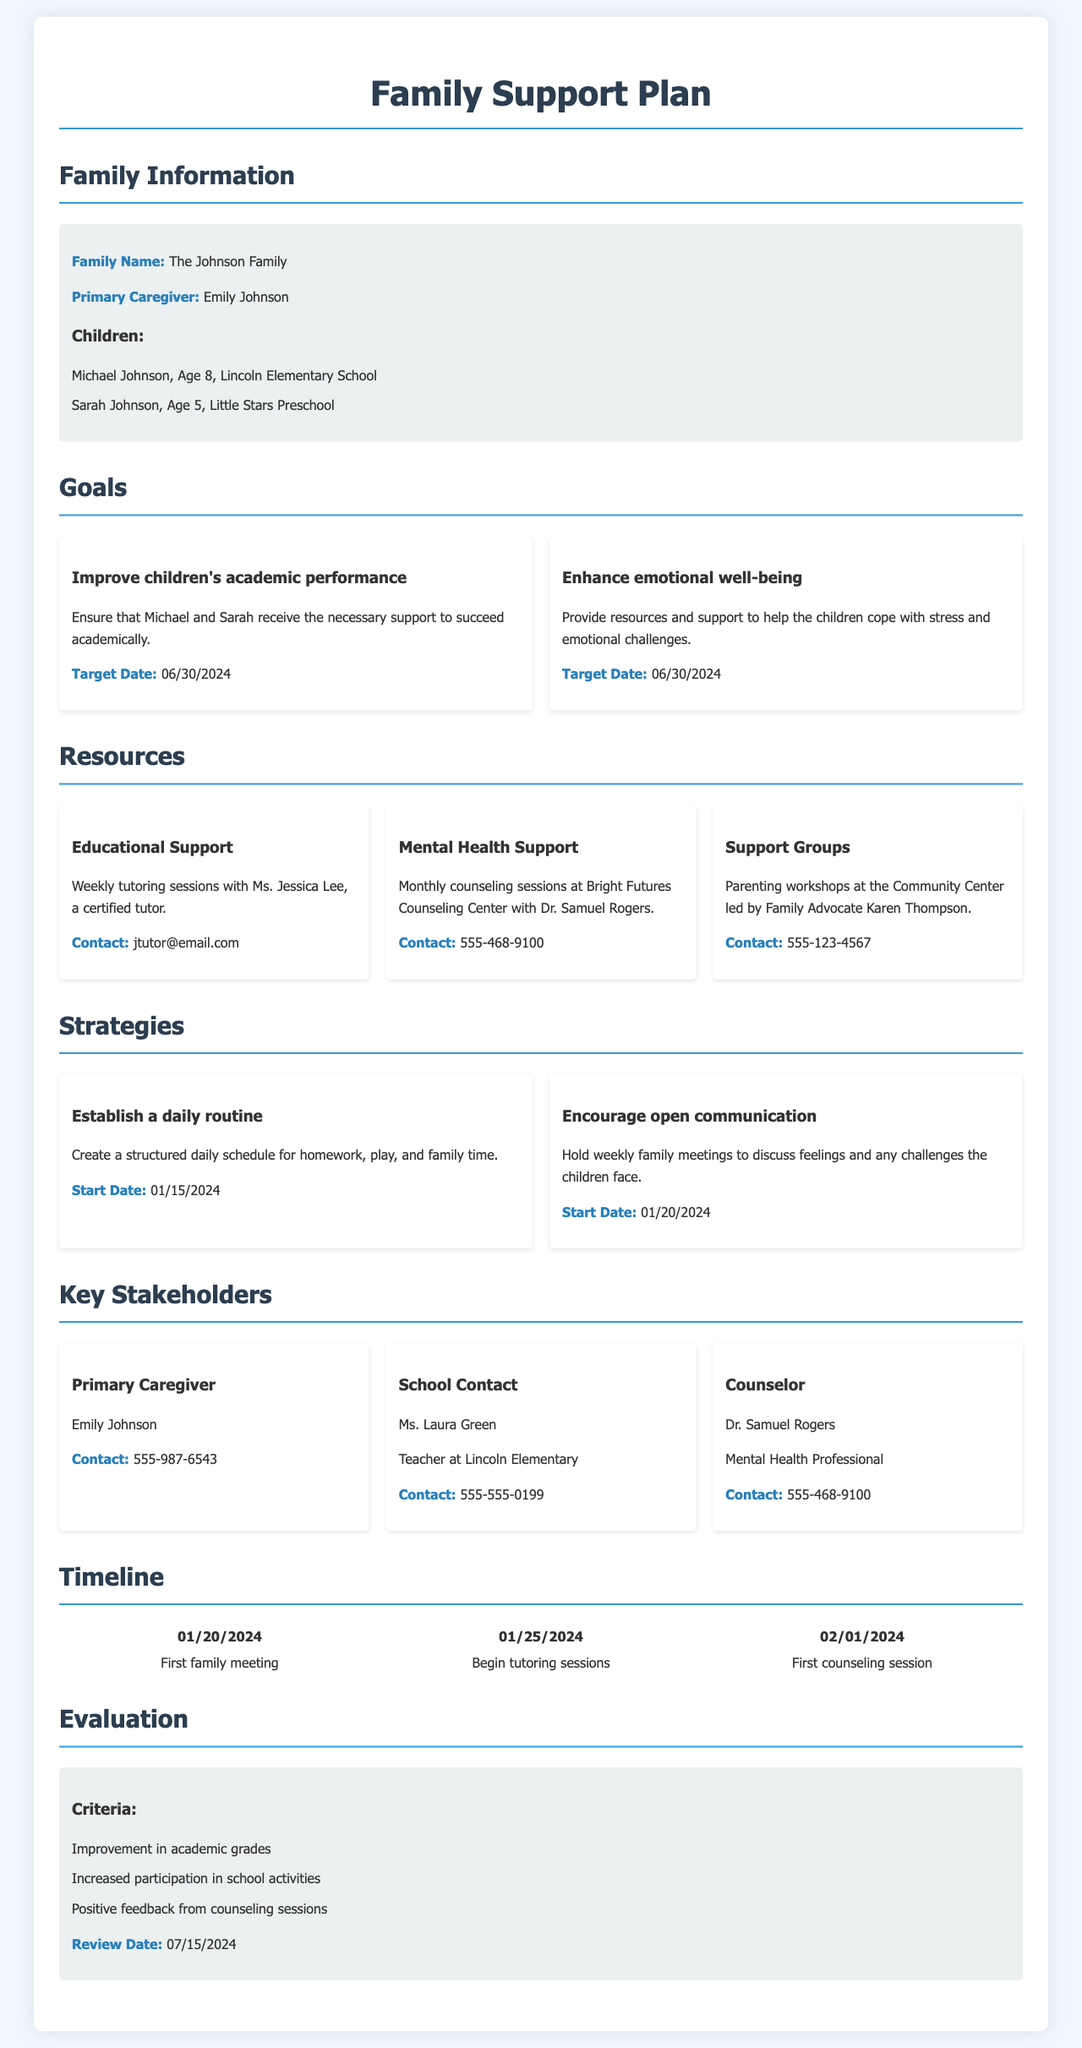what is the primary caregiver's name? The primary caregiver's name is mentioned in the Family Information section of the document.
Answer: Emily Johnson how many children does the Johnson family have? The number of children is listed under the Family Information section.
Answer: 2 what is the target date for improving children's academic performance? The target date for this goal is specified in the Goals section of the document.
Answer: 06/30/2024 who provides educational support to the children? The document specifies the person who provides educational support in the Resources section.
Answer: Ms. Jessica Lee what is the start date for establishing a daily routine? The start date for this strategy is provided in the Strategies section of the document.
Answer: 01/15/2024 which stakeholder is the school contact? The stakeholder listed as the school contact is mentioned in the Key Stakeholders section.
Answer: Ms. Laura Green how often will counseling sessions occur? The document provides the frequency of counseling sessions in the Resources section.
Answer: Monthly what is the evaluation review date? The review date is specified in the Evaluation section of the document.
Answer: 07/15/2024 what is the first event listed in the timeline? The timeline details the sequence of events, with the first event clearly stated.
Answer: First family meeting 